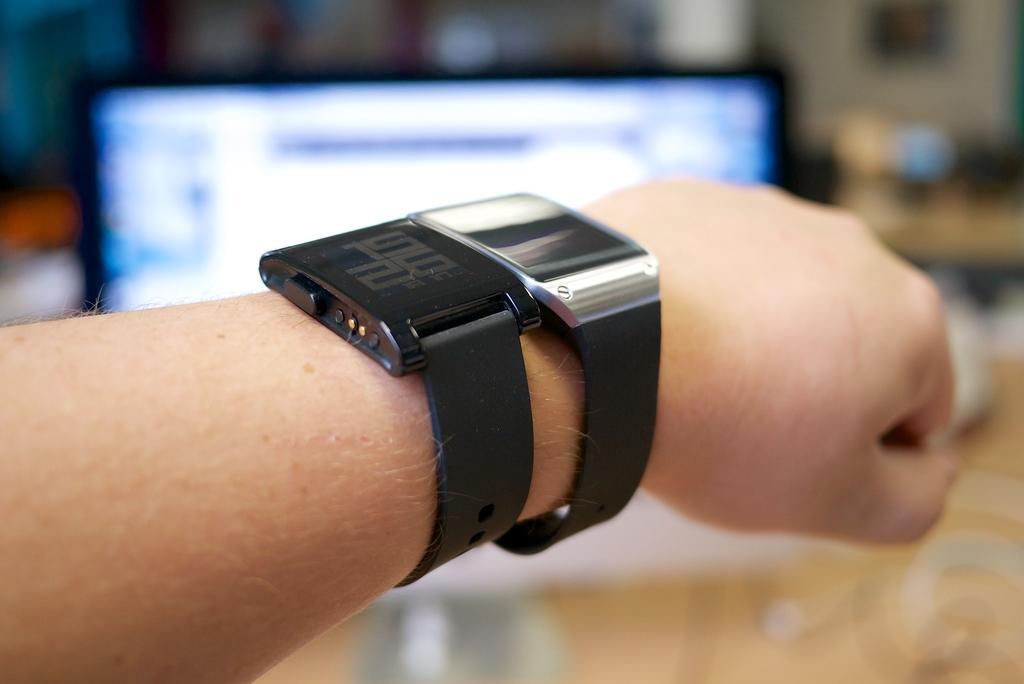Please provide a concise description of this image. In this image, we can see a hand contains watches. In the background, image is blurred. 